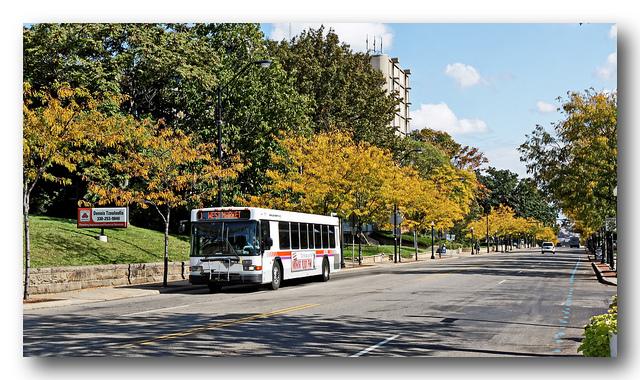What are the weather conditions in this picture?
Answer briefly. Sunny. What are below the trees?
Answer briefly. Bus. Are there people on the bus?
Be succinct. Yes. Is the road curving?
Be succinct. No. What type of trees are shown?
Concise answer only. Oak. There are people in the bus?
Short answer required. Yes. Is this an old photo?
Give a very brief answer. No. What color is the fire hydrant?
Short answer required. White. Are there any vehicles in this photo?
Concise answer only. Yes. Is this a recent photo?
Concise answer only. Yes. What time of day is this?
Quick response, please. Noon. Is the ground dry?
Answer briefly. Yes. Is it day or night in this scene?
Short answer required. Day. Is there a stop sign on the road?
Short answer required. No. Where is the bus going?
Keep it brief. West market. What is the object with wheels called?
Write a very short answer. Bus. Approximately what year was this photo taken?
Short answer required. 2015. What is sitting on the tire?
Short answer required. Bus. 